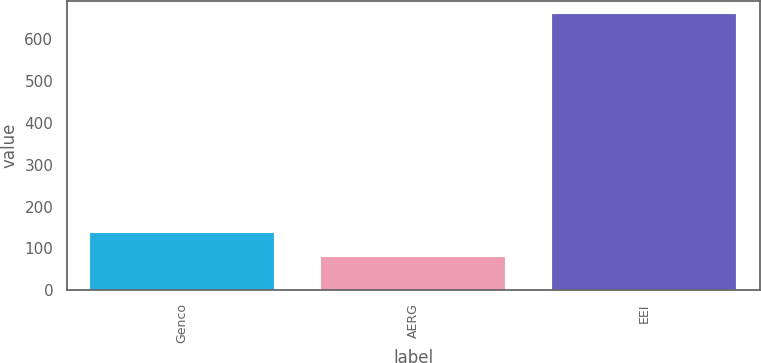<chart> <loc_0><loc_0><loc_500><loc_500><bar_chart><fcel>Genco<fcel>AERG<fcel>EEI<nl><fcel>138<fcel>80<fcel>660<nl></chart> 